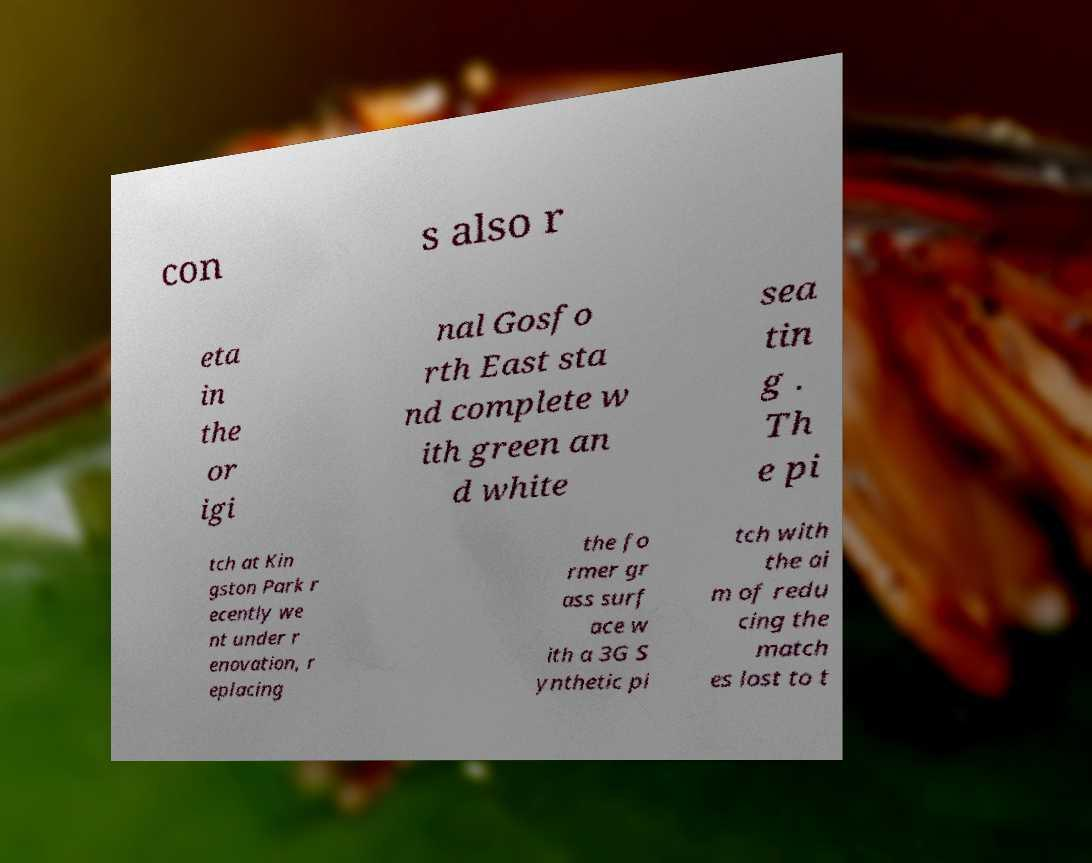Please read and relay the text visible in this image. What does it say? con s also r eta in the or igi nal Gosfo rth East sta nd complete w ith green an d white sea tin g . Th e pi tch at Kin gston Park r ecently we nt under r enovation, r eplacing the fo rmer gr ass surf ace w ith a 3G S ynthetic pi tch with the ai m of redu cing the match es lost to t 